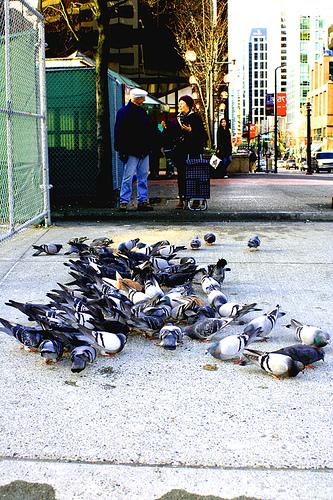Why are there so many pigeons in one spot?
Quick response, please. Eating. Is this in the city or country?
Be succinct. City. What is the relationship of the man and woman in the picture?
Quick response, please. Married. 